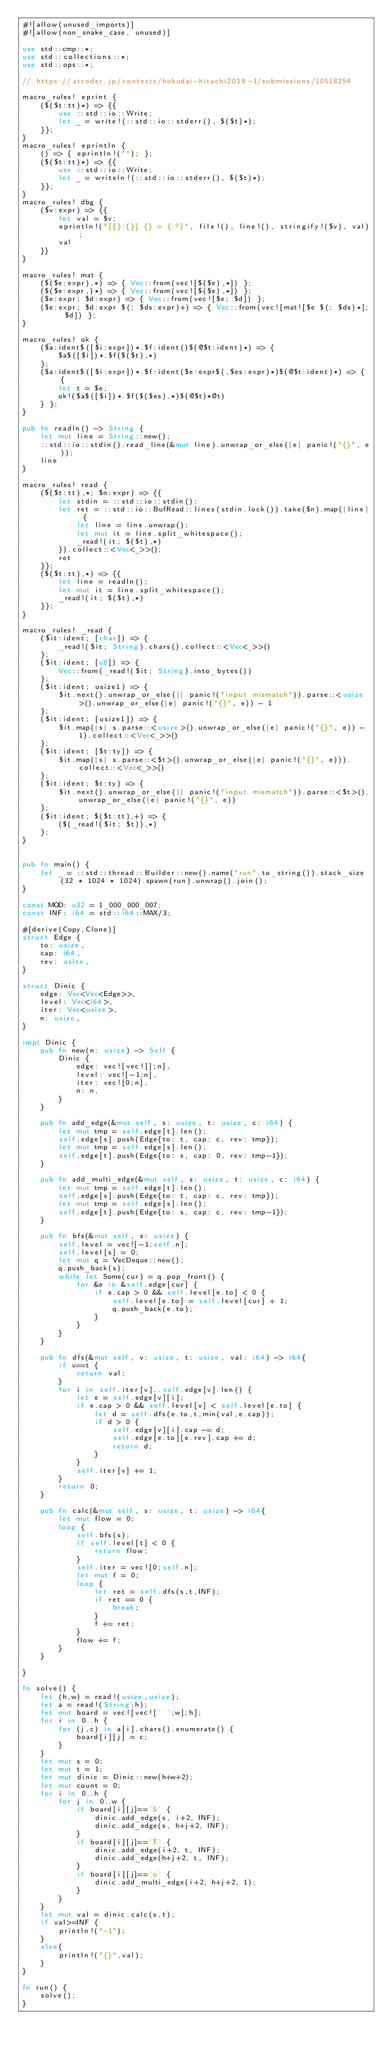<code> <loc_0><loc_0><loc_500><loc_500><_Rust_>#![allow(unused_imports)]
#![allow(non_snake_case, unused)]

use std::cmp::*;
use std::collections::*;
use std::ops::*;

// https://atcoder.jp/contests/hokudai-hitachi2019-1/submissions/10518254

macro_rules! eprint {
	($($t:tt)*) => {{
		use ::std::io::Write;
		let _ = write!(::std::io::stderr(), $($t)*);
	}};
}
macro_rules! eprintln {
	() => { eprintln!(""); };
	($($t:tt)*) => {{
		use ::std::io::Write;
		let _ = writeln!(::std::io::stderr(), $($t)*);
	}};
}
macro_rules! dbg {
	($v:expr) => {{
		let val = $v;
		eprintln!("[{}:{}] {} = {:?}", file!(), line!(), stringify!($v), val);
		val
	}}
}

macro_rules! mat {
	($($e:expr),*) => { Vec::from(vec![$($e),*]) };
	($($e:expr,)*) => { Vec::from(vec![$($e),*]) };
	($e:expr; $d:expr) => { Vec::from(vec![$e; $d]) };
	($e:expr; $d:expr $(; $ds:expr)+) => { Vec::from(vec![mat![$e $(; $ds)*]; $d]) };
}

macro_rules! ok {
	($a:ident$([$i:expr])*.$f:ident()$(@$t:ident)*) => {
		$a$([$i])*.$f($($t),*)
	};
	($a:ident$([$i:expr])*.$f:ident($e:expr$(,$es:expr)*)$(@$t:ident)*) => { {
		let t = $e;
		ok!($a$([$i])*.$f($($es),*)$(@$t)*@t)
	} };
}

pub fn readln() -> String {
	let mut line = String::new();
	::std::io::stdin().read_line(&mut line).unwrap_or_else(|e| panic!("{}", e));
	line
}

macro_rules! read {
	($($t:tt),*; $n:expr) => {{
		let stdin = ::std::io::stdin();
		let ret = ::std::io::BufRead::lines(stdin.lock()).take($n).map(|line| {
			let line = line.unwrap();
			let mut it = line.split_whitespace();
			_read!(it; $($t),*)
		}).collect::<Vec<_>>();
		ret
	}};
	($($t:tt),*) => {{
		let line = readln();
		let mut it = line.split_whitespace();
		_read!(it; $($t),*)
	}};
}

macro_rules! _read {
	($it:ident; [char]) => {
		_read!($it; String).chars().collect::<Vec<_>>()
	};
	($it:ident; [u8]) => {
		Vec::from(_read!($it; String).into_bytes())
	};
	($it:ident; usize1) => {
		$it.next().unwrap_or_else(|| panic!("input mismatch")).parse::<usize>().unwrap_or_else(|e| panic!("{}", e)) - 1
	};
	($it:ident; [usize1]) => {
		$it.map(|s| s.parse::<usize>().unwrap_or_else(|e| panic!("{}", e)) - 1).collect::<Vec<_>>()
	};
	($it:ident; [$t:ty]) => {
		$it.map(|s| s.parse::<$t>().unwrap_or_else(|e| panic!("{}", e))).collect::<Vec<_>>()
	};
	($it:ident; $t:ty) => {
		$it.next().unwrap_or_else(|| panic!("input mismatch")).parse::<$t>().unwrap_or_else(|e| panic!("{}", e))
	};
	($it:ident; $($t:tt),+) => {
		($(_read!($it; $t)),*)
	};
}


pub fn main() {
	let _ = ::std::thread::Builder::new().name("run".to_string()).stack_size(32 * 1024 * 1024).spawn(run).unwrap().join();
}

const MOD: u32 = 1_000_000_007;
const INF: i64 = std::i64::MAX/3;

#[derive(Copy,Clone)]
struct Edge {
	to: usize,
	cap: i64,
	rev: usize,
}

struct Dinic {
	edge: Vec<Vec<Edge>>,
	level: Vec<i64>,
	iter: Vec<usize>,
	n: usize,
}

impl Dinic {
	pub fn new(n: usize) -> Self {
		Dinic {
			edge: vec![vec![];n],
			level: vec![-1;n],
			iter: vec![0;n],
			n: n,
		}
	}

	pub fn add_edge(&mut self, s: usize, t: usize, c: i64) {
		let mut tmp = self.edge[t].len();
		self.edge[s].push(Edge{to: t, cap: c, rev: tmp});
		let mut tmp = self.edge[s].len();
		self.edge[t].push(Edge{to: s, cap: 0, rev: tmp-1});
	}

	pub fn add_multi_edge(&mut self, s: usize, t: usize, c: i64) {
		let mut tmp = self.edge[t].len();
		self.edge[s].push(Edge{to: t, cap: c, rev: tmp});
		let mut tmp = self.edge[s].len();
		self.edge[t].push(Edge{to: s, cap: c, rev: tmp-1});
	}

	pub fn bfs(&mut self, s: usize) {
		self.level = vec![-1;self.n];
		self.level[s] = 0;
		let mut q = VecDeque::new();
		q.push_back(s);
		while let Some(cur) = q.pop_front() {
			for &e in &self.edge[cur] {
				if e.cap > 0 && self.level[e.to] < 0 {
					self.level[e.to] = self.level[cur] + 1;
					q.push_back(e.to);
				}
			}
		}
	} 

	pub fn dfs(&mut self, v: usize, t: usize, val: i64) -> i64{
		if v==t {
			return val;
		}
		for i in self.iter[v]..self.edge[v].len() {
			let e = self.edge[v][i];
			if e.cap > 0 && self.level[v] < self.level[e.to] {
				let d = self.dfs(e.to,t,min(val,e.cap));
				if d > 0 {
					self.edge[v][i].cap -= d;
					self.edge[e.to][e.rev].cap += d;
					return d;
				}
			}
			self.iter[v] += 1;
		}
		return 0;
	}

	pub fn calc(&mut self, s: usize, t: usize) -> i64{
		let mut flow = 0;
		loop {
			self.bfs(s);
			if self.level[t] < 0 {
				return flow;
			}
			self.iter = vec![0;self.n];
			let mut f = 0;
			loop {
				let ret = self.dfs(s,t,INF);
				if ret == 0 {
					break;
				}
				f += ret;
			}
			flow += f;
		}
	}

}

fn solve() {
	let (h,w) = read!(usize,usize);
	let a = read!(String;h);
	let mut board = vec![vec![' ';w];h];
	for i in 0..h {
		for (j,c) in a[i].chars().enumerate() {
			board[i][j] = c;
		}
	}
	let mut s = 0;
	let mut t = 1;
	let mut dinic = Dinic::new(h+w+2);
	let mut count = 0;
	for i in 0..h {
		for j in 0..w {
			if board[i][j]=='S' {
				dinic.add_edge(s, i+2, INF);
				dinic.add_edge(s, h+j+2, INF);
			}
			if board[i][j]=='T' {
				dinic.add_edge(i+2, t, INF);
				dinic.add_edge(h+j+2, t, INF);
			}
			if board[i][j]=='o' {
				dinic.add_multi_edge(i+2, h+j+2, 1);
			}
		}
	}
	let mut val = dinic.calc(s,t);
	if val>=INF {
		println!("-1");
	}
	else{
		println!("{}",val);
	}
}

fn run() {
    solve();
}
</code> 